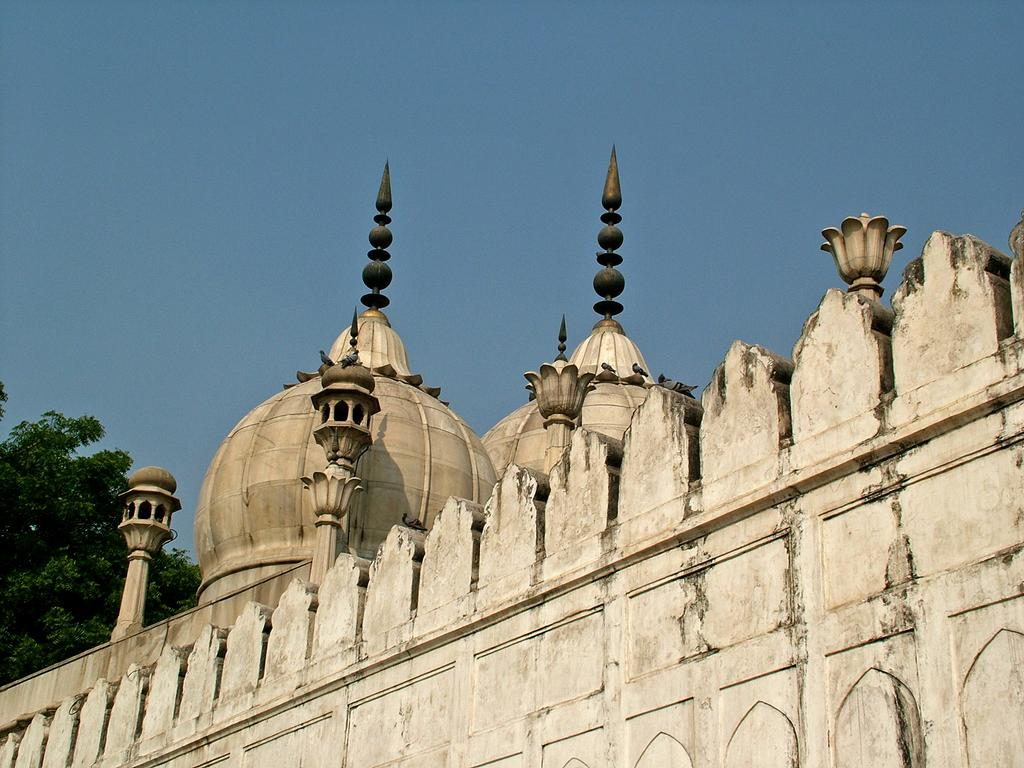What type of building is in the picture? There is a mosque in the picture. Can you describe the appearance of the mosque? The mosque appears to be old. What is located on the left side of the mosque? There are trees on the left side of the mosque. What can be seen in the background of the picture? The sky is visible in the background of the picture. What is the color of the sky in the picture? The sky is blue in color. What type of boundary is depicted in the image? There is no boundary depicted in the image; it features a mosque, trees, and a blue sky. How does the nation contribute to the maintenance of the mosque in the image? The image does not provide information about the nation or its involvement in the mosque's maintenance. 